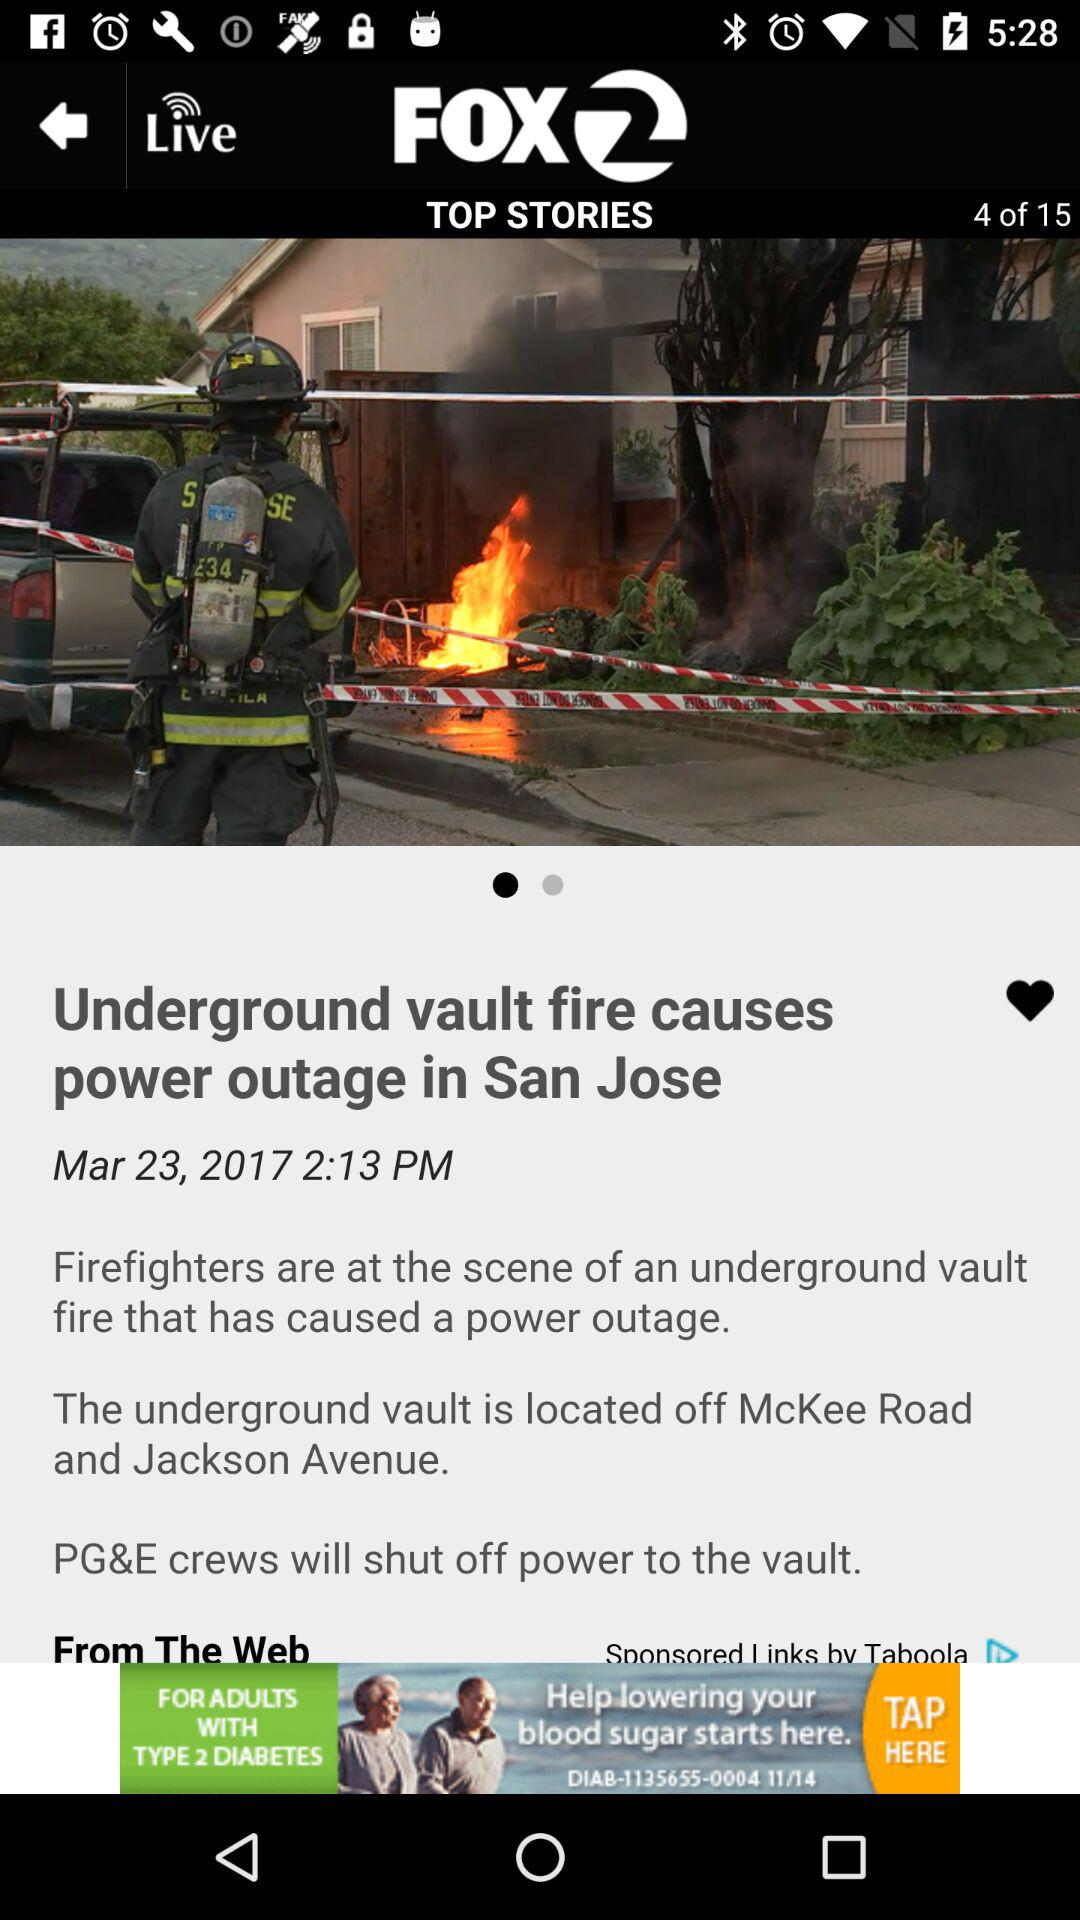Where is the underground vault located? The underground vault is located off McKee Road and Jackson Avenue. 